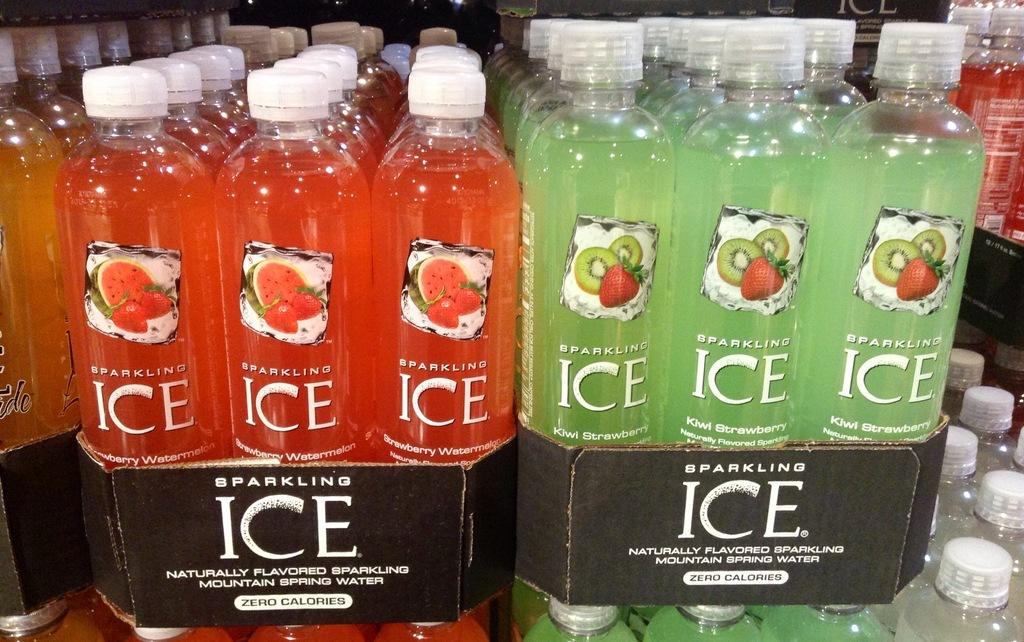<image>
Offer a succinct explanation of the picture presented. Red and green Sparkling Ice water being put on sale. 